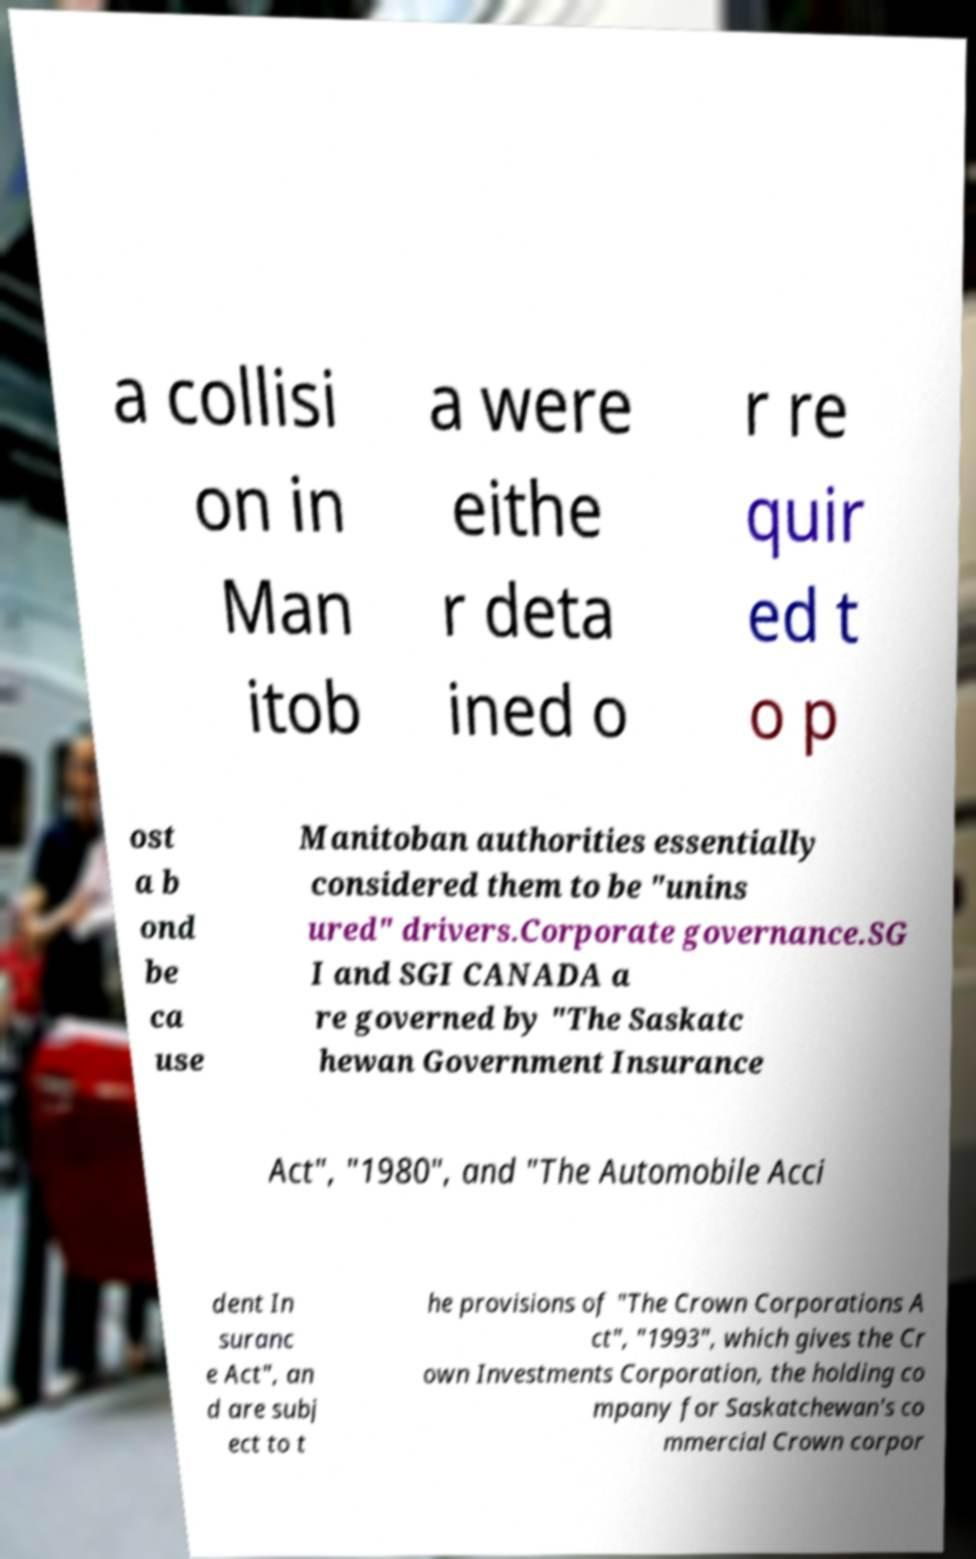There's text embedded in this image that I need extracted. Can you transcribe it verbatim? a collisi on in Man itob a were eithe r deta ined o r re quir ed t o p ost a b ond be ca use Manitoban authorities essentially considered them to be "unins ured" drivers.Corporate governance.SG I and SGI CANADA a re governed by "The Saskatc hewan Government Insurance Act", "1980", and "The Automobile Acci dent In suranc e Act", an d are subj ect to t he provisions of "The Crown Corporations A ct", "1993", which gives the Cr own Investments Corporation, the holding co mpany for Saskatchewan's co mmercial Crown corpor 